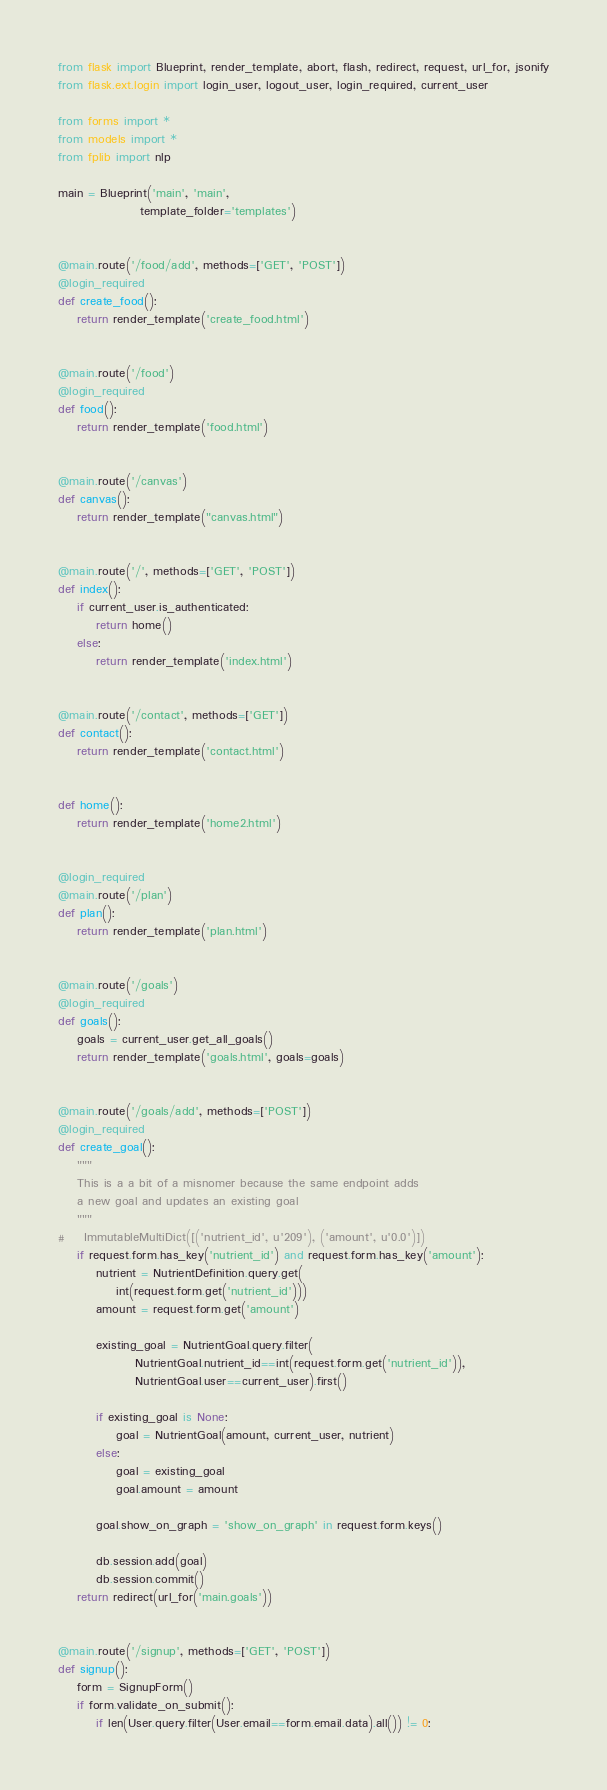<code> <loc_0><loc_0><loc_500><loc_500><_Python_>from flask import Blueprint, render_template, abort, flash, redirect, request, url_for, jsonify
from flask.ext.login import login_user, logout_user, login_required, current_user

from forms import *
from models import *
from fplib import nlp

main = Blueprint('main', 'main',
                 template_folder='templates')


@main.route('/food/add', methods=['GET', 'POST'])
@login_required
def create_food():
    return render_template('create_food.html')


@main.route('/food')
@login_required
def food():
    return render_template('food.html')


@main.route('/canvas')
def canvas():
    return render_template("canvas.html")


@main.route('/', methods=['GET', 'POST'])
def index():
    if current_user.is_authenticated:
        return home()
    else:
        return render_template('index.html')


@main.route('/contact', methods=['GET'])
def contact():
    return render_template('contact.html')


def home():
    return render_template('home2.html')


@login_required
@main.route('/plan')
def plan():
    return render_template('plan.html')


@main.route('/goals')
@login_required
def goals():
    goals = current_user.get_all_goals()
    return render_template('goals.html', goals=goals)


@main.route('/goals/add', methods=['POST'])
@login_required
def create_goal():
    """
    This is a a bit of a misnomer because the same endpoint adds
    a new goal and updates an existing goal
    """
#    ImmutableMultiDict([('nutrient_id', u'209'), ('amount', u'0.0')])
    if request.form.has_key('nutrient_id') and request.form.has_key('amount'):
        nutrient = NutrientDefinition.query.get(
            int(request.form.get('nutrient_id')))
        amount = request.form.get('amount')

        existing_goal = NutrientGoal.query.filter(
                NutrientGoal.nutrient_id==int(request.form.get('nutrient_id')),
                NutrientGoal.user==current_user).first()

        if existing_goal is None:
            goal = NutrientGoal(amount, current_user, nutrient)
        else:
            goal = existing_goal
            goal.amount = amount

        goal.show_on_graph = 'show_on_graph' in request.form.keys()

        db.session.add(goal)
        db.session.commit()
    return redirect(url_for('main.goals'))


@main.route('/signup', methods=['GET', 'POST'])
def signup():
    form = SignupForm()
    if form.validate_on_submit():
        if len(User.query.filter(User.email==form.email.data).all()) != 0:</code> 